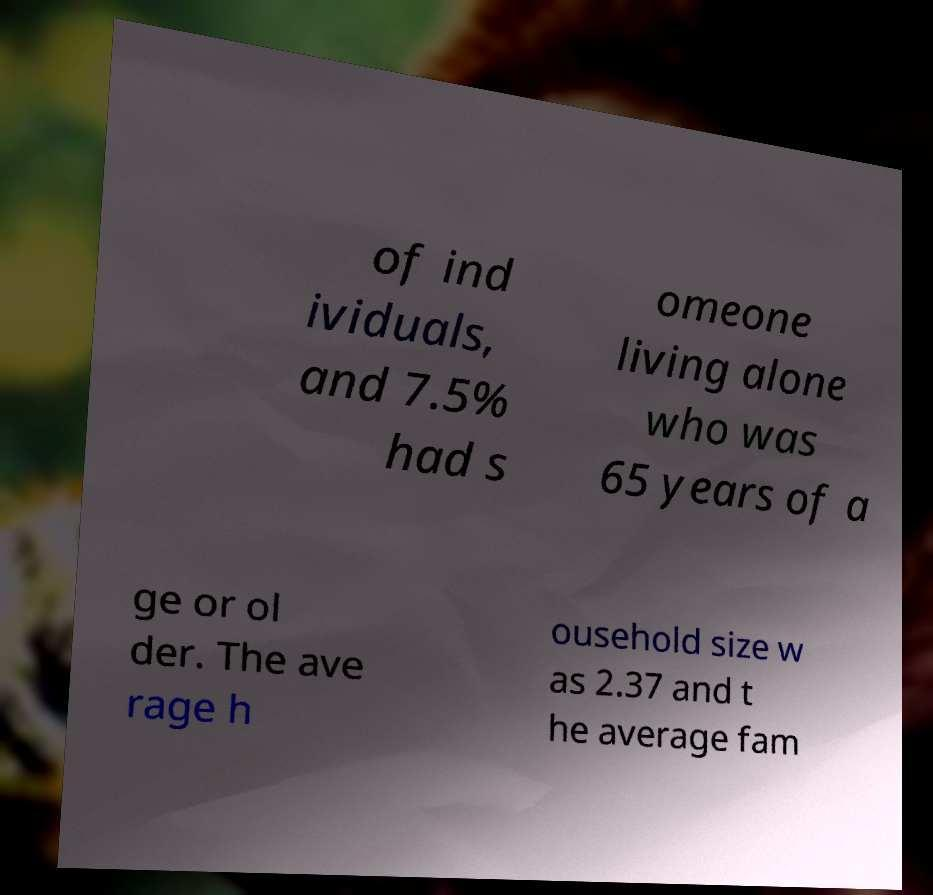For documentation purposes, I need the text within this image transcribed. Could you provide that? of ind ividuals, and 7.5% had s omeone living alone who was 65 years of a ge or ol der. The ave rage h ousehold size w as 2.37 and t he average fam 